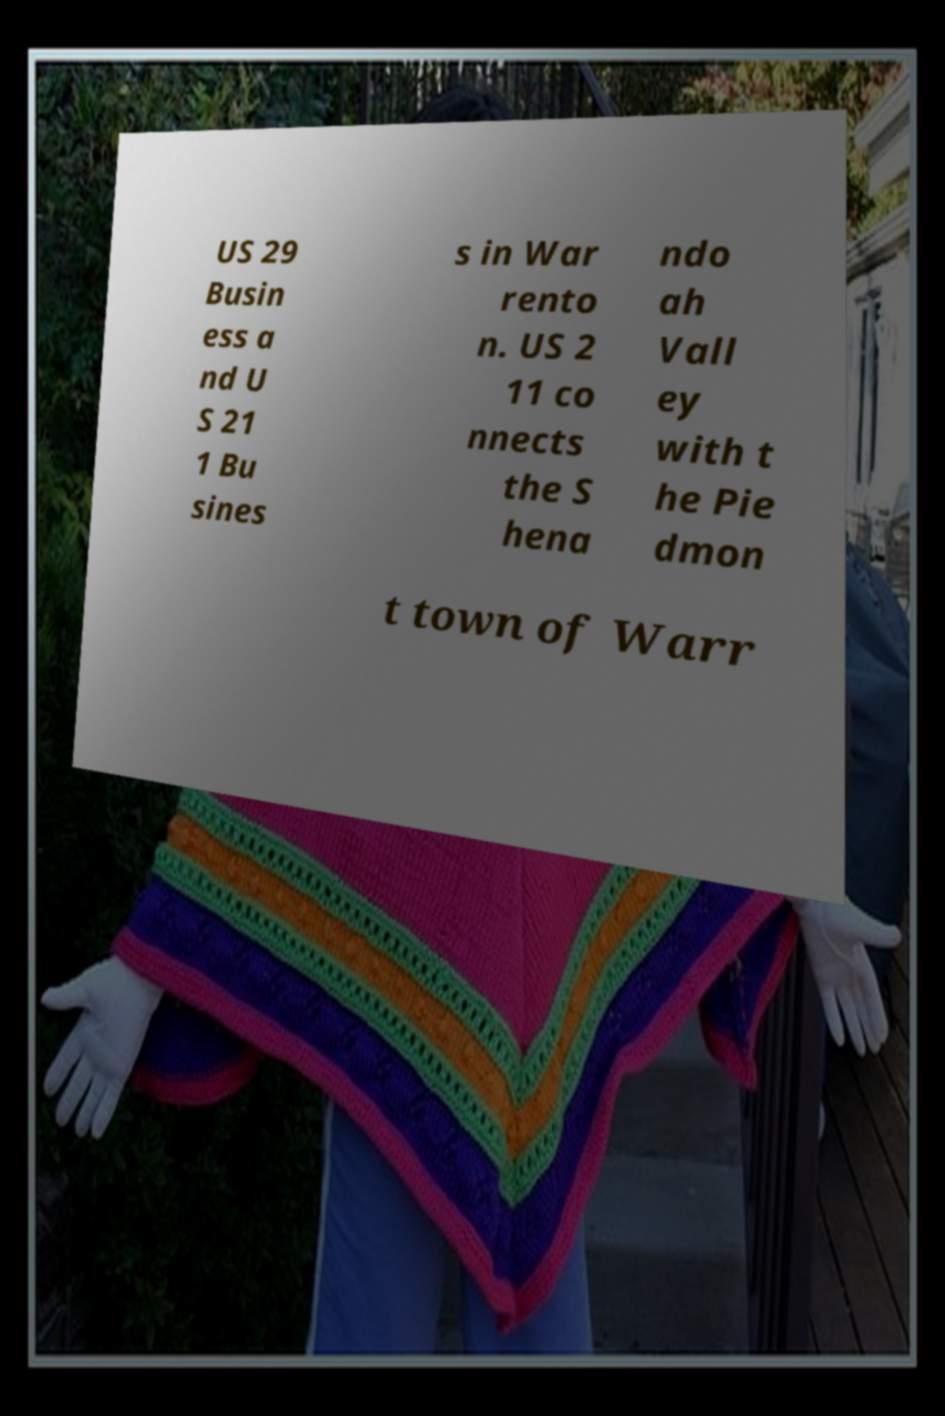Please read and relay the text visible in this image. What does it say? US 29 Busin ess a nd U S 21 1 Bu sines s in War rento n. US 2 11 co nnects the S hena ndo ah Vall ey with t he Pie dmon t town of Warr 